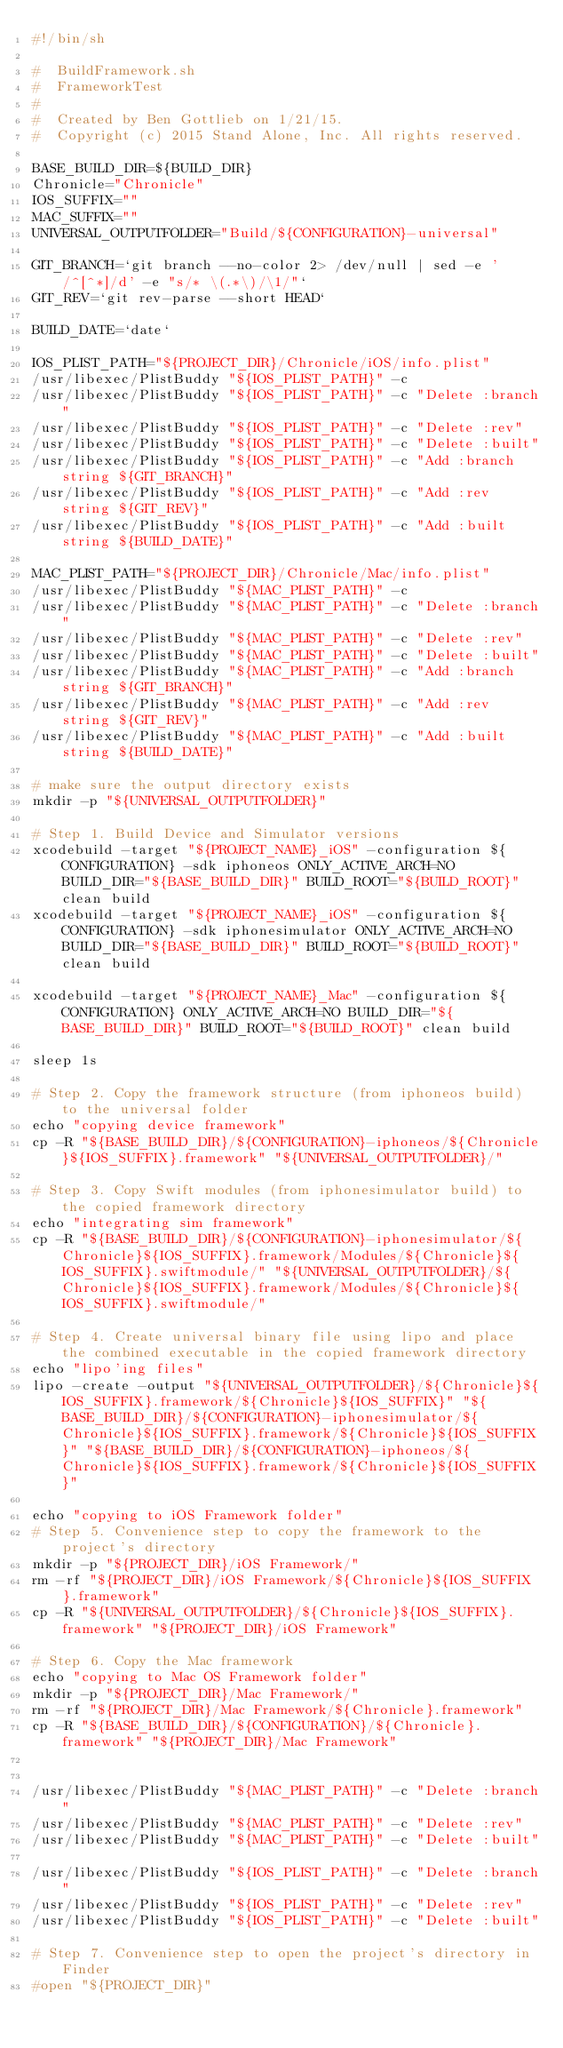<code> <loc_0><loc_0><loc_500><loc_500><_Bash_>#!/bin/sh

#  BuildFramework.sh
#  FrameworkTest
#
#  Created by Ben Gottlieb on 1/21/15.
#  Copyright (c) 2015 Stand Alone, Inc. All rights reserved.

BASE_BUILD_DIR=${BUILD_DIR}
Chronicle="Chronicle"
IOS_SUFFIX=""
MAC_SUFFIX=""
UNIVERSAL_OUTPUTFOLDER="Build/${CONFIGURATION}-universal"

GIT_BRANCH=`git branch --no-color 2> /dev/null | sed -e '/^[^*]/d' -e "s/* \(.*\)/\1/"`
GIT_REV=`git rev-parse --short HEAD`

BUILD_DATE=`date`

IOS_PLIST_PATH="${PROJECT_DIR}/Chronicle/iOS/info.plist"
/usr/libexec/PlistBuddy "${IOS_PLIST_PATH}" -c
/usr/libexec/PlistBuddy "${IOS_PLIST_PATH}" -c "Delete :branch"
/usr/libexec/PlistBuddy "${IOS_PLIST_PATH}" -c "Delete :rev"
/usr/libexec/PlistBuddy "${IOS_PLIST_PATH}" -c "Delete :built"
/usr/libexec/PlistBuddy "${IOS_PLIST_PATH}" -c "Add :branch string ${GIT_BRANCH}"
/usr/libexec/PlistBuddy "${IOS_PLIST_PATH}" -c "Add :rev string ${GIT_REV}"
/usr/libexec/PlistBuddy "${IOS_PLIST_PATH}" -c "Add :built string ${BUILD_DATE}"

MAC_PLIST_PATH="${PROJECT_DIR}/Chronicle/Mac/info.plist"
/usr/libexec/PlistBuddy "${MAC_PLIST_PATH}" -c
/usr/libexec/PlistBuddy "${MAC_PLIST_PATH}" -c "Delete :branch"
/usr/libexec/PlistBuddy "${MAC_PLIST_PATH}" -c "Delete :rev"
/usr/libexec/PlistBuddy "${MAC_PLIST_PATH}" -c "Delete :built"
/usr/libexec/PlistBuddy "${MAC_PLIST_PATH}" -c "Add :branch string ${GIT_BRANCH}"
/usr/libexec/PlistBuddy "${MAC_PLIST_PATH}" -c "Add :rev string ${GIT_REV}"
/usr/libexec/PlistBuddy "${MAC_PLIST_PATH}" -c "Add :built string ${BUILD_DATE}"

# make sure the output directory exists
mkdir -p "${UNIVERSAL_OUTPUTFOLDER}"

# Step 1. Build Device and Simulator versions
xcodebuild -target "${PROJECT_NAME}_iOS" -configuration ${CONFIGURATION} -sdk iphoneos ONLY_ACTIVE_ARCH=NO  BUILD_DIR="${BASE_BUILD_DIR}" BUILD_ROOT="${BUILD_ROOT}" clean build
xcodebuild -target "${PROJECT_NAME}_iOS" -configuration ${CONFIGURATION} -sdk iphonesimulator ONLY_ACTIVE_ARCH=NO BUILD_DIR="${BASE_BUILD_DIR}" BUILD_ROOT="${BUILD_ROOT}" clean build

xcodebuild -target "${PROJECT_NAME}_Mac" -configuration ${CONFIGURATION} ONLY_ACTIVE_ARCH=NO BUILD_DIR="${BASE_BUILD_DIR}" BUILD_ROOT="${BUILD_ROOT}" clean build

sleep 1s

# Step 2. Copy the framework structure (from iphoneos build) to the universal folder
echo "copying device framework"
cp -R "${BASE_BUILD_DIR}/${CONFIGURATION}-iphoneos/${Chronicle}${IOS_SUFFIX}.framework" "${UNIVERSAL_OUTPUTFOLDER}/"

# Step 3. Copy Swift modules (from iphonesimulator build) to the copied framework directory
echo "integrating sim framework"
cp -R "${BASE_BUILD_DIR}/${CONFIGURATION}-iphonesimulator/${Chronicle}${IOS_SUFFIX}.framework/Modules/${Chronicle}${IOS_SUFFIX}.swiftmodule/" "${UNIVERSAL_OUTPUTFOLDER}/${Chronicle}${IOS_SUFFIX}.framework/Modules/${Chronicle}${IOS_SUFFIX}.swiftmodule/"

# Step 4. Create universal binary file using lipo and place the combined executable in the copied framework directory
echo "lipo'ing files"
lipo -create -output "${UNIVERSAL_OUTPUTFOLDER}/${Chronicle}${IOS_SUFFIX}.framework/${Chronicle}${IOS_SUFFIX}" "${BASE_BUILD_DIR}/${CONFIGURATION}-iphonesimulator/${Chronicle}${IOS_SUFFIX}.framework/${Chronicle}${IOS_SUFFIX}" "${BASE_BUILD_DIR}/${CONFIGURATION}-iphoneos/${Chronicle}${IOS_SUFFIX}.framework/${Chronicle}${IOS_SUFFIX}"

echo "copying to iOS Framework folder"
# Step 5. Convenience step to copy the framework to the project's directory
mkdir -p "${PROJECT_DIR}/iOS Framework/"
rm -rf "${PROJECT_DIR}/iOS Framework/${Chronicle}${IOS_SUFFIX}.framework"
cp -R "${UNIVERSAL_OUTPUTFOLDER}/${Chronicle}${IOS_SUFFIX}.framework" "${PROJECT_DIR}/iOS Framework"

# Step 6. Copy the Mac framework
echo "copying to Mac OS Framework folder"
mkdir -p "${PROJECT_DIR}/Mac Framework/"
rm -rf "${PROJECT_DIR}/Mac Framework/${Chronicle}.framework"
cp -R "${BASE_BUILD_DIR}/${CONFIGURATION}/${Chronicle}.framework" "${PROJECT_DIR}/Mac Framework"


/usr/libexec/PlistBuddy "${MAC_PLIST_PATH}" -c "Delete :branch"
/usr/libexec/PlistBuddy "${MAC_PLIST_PATH}" -c "Delete :rev"
/usr/libexec/PlistBuddy "${MAC_PLIST_PATH}" -c "Delete :built"

/usr/libexec/PlistBuddy "${IOS_PLIST_PATH}" -c "Delete :branch"
/usr/libexec/PlistBuddy "${IOS_PLIST_PATH}" -c "Delete :rev"
/usr/libexec/PlistBuddy "${IOS_PLIST_PATH}" -c "Delete :built"

# Step 7. Convenience step to open the project's directory in Finder
#open "${PROJECT_DIR}"</code> 